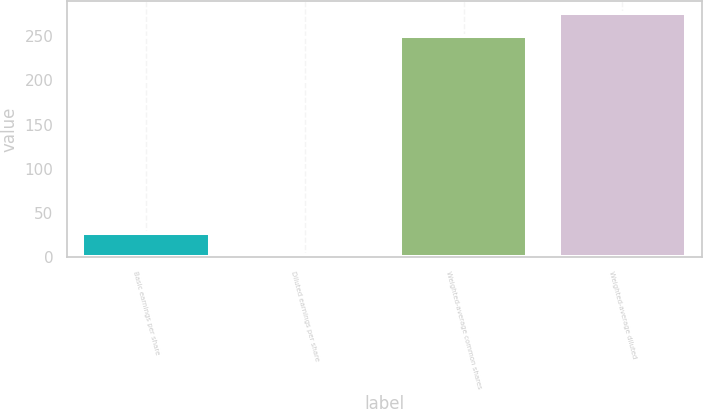Convert chart to OTSL. <chart><loc_0><loc_0><loc_500><loc_500><bar_chart><fcel>Basic earnings per share<fcel>Diluted earnings per share<fcel>Weighted-average common shares<fcel>Weighted-average diluted<nl><fcel>27.16<fcel>1.88<fcel>250.8<fcel>276.08<nl></chart> 